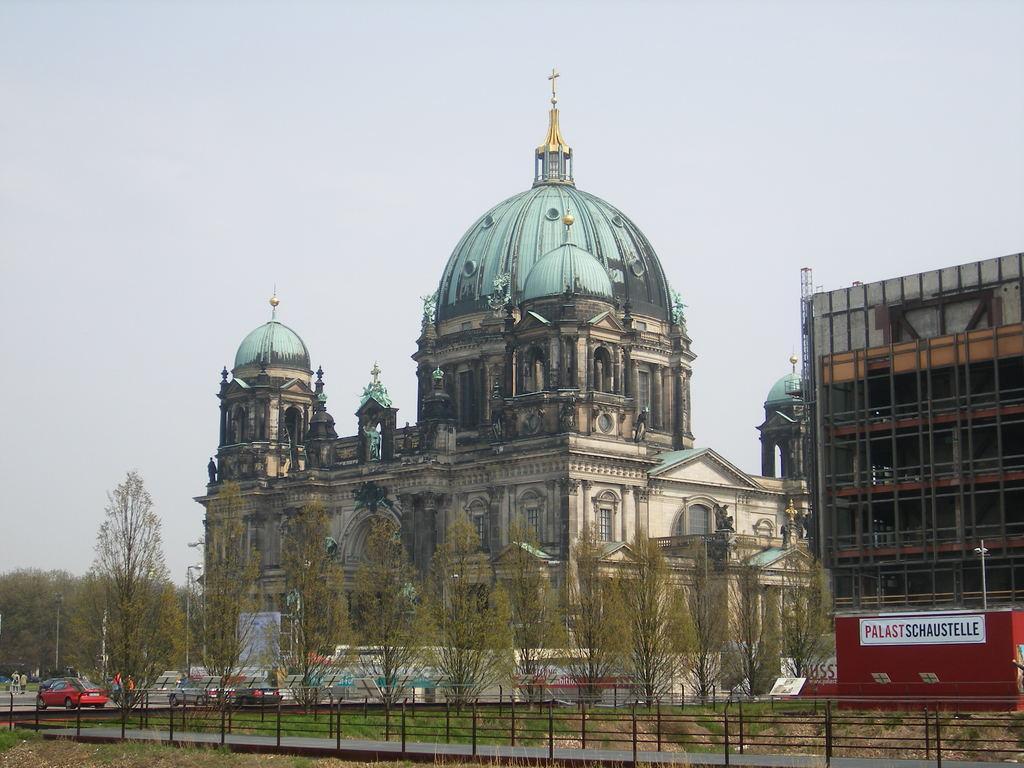Can you describe this image briefly? In this image we can see the ancient architecture of the building/church in which the upper region of it resembles like a church with the sign. And on the right we can see the red color sheet in which some text is written. And in the foreground we can see fence with trees and surrounding greenery. And we can see few people and clouds in the sky. 